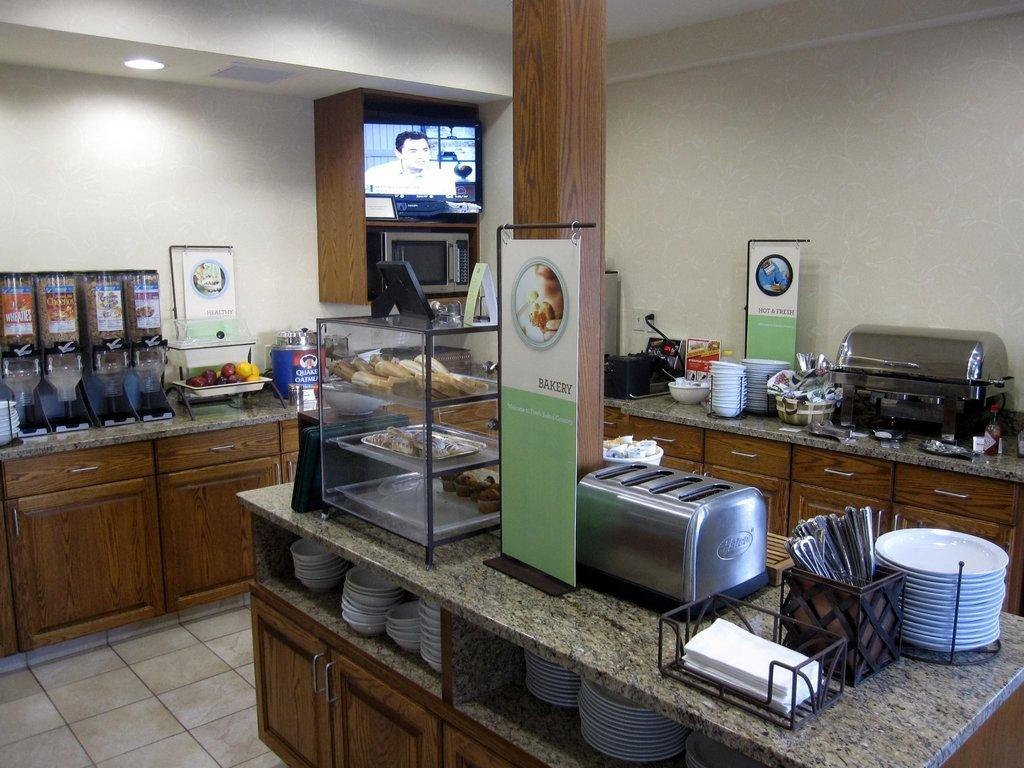<image>
Describe the image concisely. The signs for the buffets show for bakery foods and hot foods. 